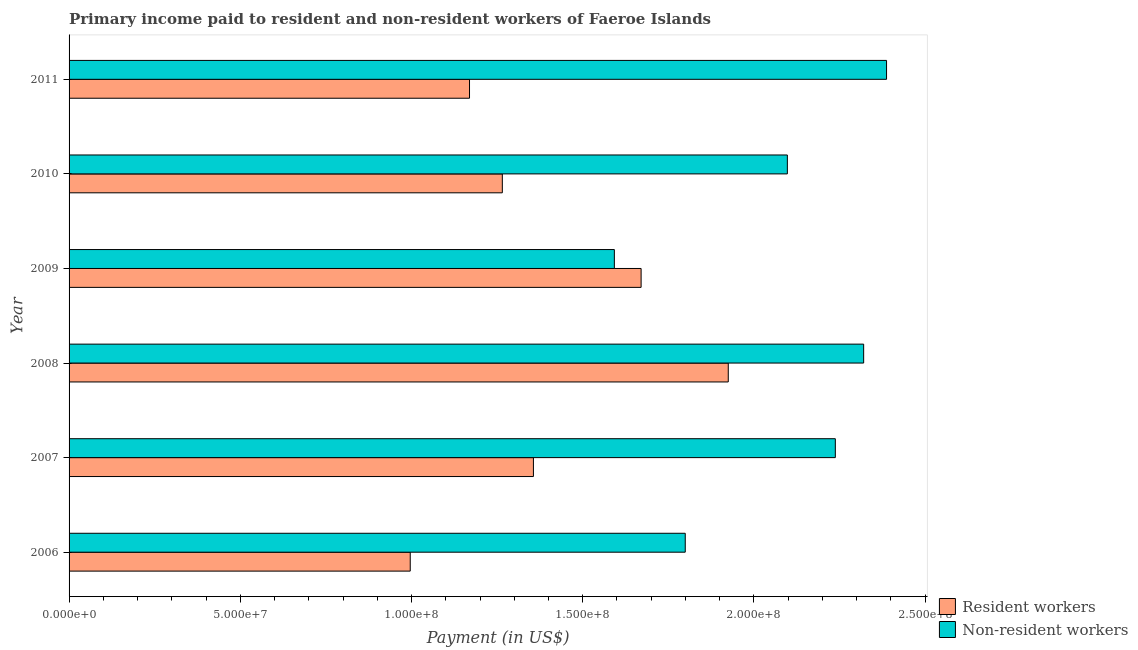How many different coloured bars are there?
Provide a short and direct response. 2. How many groups of bars are there?
Offer a very short reply. 6. Are the number of bars per tick equal to the number of legend labels?
Make the answer very short. Yes. Are the number of bars on each tick of the Y-axis equal?
Your answer should be compact. Yes. How many bars are there on the 1st tick from the top?
Your answer should be compact. 2. How many bars are there on the 2nd tick from the bottom?
Ensure brevity in your answer.  2. In how many cases, is the number of bars for a given year not equal to the number of legend labels?
Keep it short and to the point. 0. What is the payment made to resident workers in 2011?
Offer a very short reply. 1.17e+08. Across all years, what is the maximum payment made to non-resident workers?
Your response must be concise. 2.39e+08. Across all years, what is the minimum payment made to resident workers?
Provide a succinct answer. 9.96e+07. In which year was the payment made to non-resident workers maximum?
Your answer should be compact. 2011. In which year was the payment made to non-resident workers minimum?
Keep it short and to the point. 2009. What is the total payment made to resident workers in the graph?
Your answer should be very brief. 8.38e+08. What is the difference between the payment made to non-resident workers in 2008 and that in 2009?
Your answer should be very brief. 7.28e+07. What is the difference between the payment made to non-resident workers in 2006 and the payment made to resident workers in 2011?
Offer a very short reply. 6.30e+07. What is the average payment made to resident workers per year?
Keep it short and to the point. 1.40e+08. In the year 2006, what is the difference between the payment made to non-resident workers and payment made to resident workers?
Provide a short and direct response. 8.03e+07. What is the ratio of the payment made to resident workers in 2006 to that in 2009?
Your response must be concise. 0.6. Is the difference between the payment made to non-resident workers in 2006 and 2009 greater than the difference between the payment made to resident workers in 2006 and 2009?
Keep it short and to the point. Yes. What is the difference between the highest and the second highest payment made to resident workers?
Give a very brief answer. 2.55e+07. What is the difference between the highest and the lowest payment made to resident workers?
Your answer should be very brief. 9.29e+07. In how many years, is the payment made to non-resident workers greater than the average payment made to non-resident workers taken over all years?
Your answer should be very brief. 4. Is the sum of the payment made to resident workers in 2006 and 2008 greater than the maximum payment made to non-resident workers across all years?
Ensure brevity in your answer.  Yes. What does the 2nd bar from the top in 2006 represents?
Offer a very short reply. Resident workers. What does the 2nd bar from the bottom in 2010 represents?
Your answer should be compact. Non-resident workers. How many bars are there?
Provide a succinct answer. 12. Are all the bars in the graph horizontal?
Your answer should be very brief. Yes. Are the values on the major ticks of X-axis written in scientific E-notation?
Give a very brief answer. Yes. How are the legend labels stacked?
Keep it short and to the point. Vertical. What is the title of the graph?
Provide a short and direct response. Primary income paid to resident and non-resident workers of Faeroe Islands. What is the label or title of the X-axis?
Your answer should be very brief. Payment (in US$). What is the label or title of the Y-axis?
Give a very brief answer. Year. What is the Payment (in US$) in Resident workers in 2006?
Keep it short and to the point. 9.96e+07. What is the Payment (in US$) in Non-resident workers in 2006?
Offer a terse response. 1.80e+08. What is the Payment (in US$) in Resident workers in 2007?
Provide a short and direct response. 1.36e+08. What is the Payment (in US$) of Non-resident workers in 2007?
Your response must be concise. 2.24e+08. What is the Payment (in US$) of Resident workers in 2008?
Offer a very short reply. 1.92e+08. What is the Payment (in US$) in Non-resident workers in 2008?
Make the answer very short. 2.32e+08. What is the Payment (in US$) in Resident workers in 2009?
Your response must be concise. 1.67e+08. What is the Payment (in US$) in Non-resident workers in 2009?
Provide a short and direct response. 1.59e+08. What is the Payment (in US$) in Resident workers in 2010?
Your answer should be very brief. 1.27e+08. What is the Payment (in US$) of Non-resident workers in 2010?
Your answer should be compact. 2.10e+08. What is the Payment (in US$) of Resident workers in 2011?
Offer a terse response. 1.17e+08. What is the Payment (in US$) in Non-resident workers in 2011?
Keep it short and to the point. 2.39e+08. Across all years, what is the maximum Payment (in US$) of Resident workers?
Make the answer very short. 1.92e+08. Across all years, what is the maximum Payment (in US$) of Non-resident workers?
Ensure brevity in your answer.  2.39e+08. Across all years, what is the minimum Payment (in US$) in Resident workers?
Keep it short and to the point. 9.96e+07. Across all years, what is the minimum Payment (in US$) in Non-resident workers?
Make the answer very short. 1.59e+08. What is the total Payment (in US$) in Resident workers in the graph?
Your answer should be very brief. 8.38e+08. What is the total Payment (in US$) in Non-resident workers in the graph?
Ensure brevity in your answer.  1.24e+09. What is the difference between the Payment (in US$) in Resident workers in 2006 and that in 2007?
Offer a terse response. -3.60e+07. What is the difference between the Payment (in US$) in Non-resident workers in 2006 and that in 2007?
Ensure brevity in your answer.  -4.38e+07. What is the difference between the Payment (in US$) of Resident workers in 2006 and that in 2008?
Offer a very short reply. -9.29e+07. What is the difference between the Payment (in US$) of Non-resident workers in 2006 and that in 2008?
Make the answer very short. -5.21e+07. What is the difference between the Payment (in US$) of Resident workers in 2006 and that in 2009?
Offer a terse response. -6.74e+07. What is the difference between the Payment (in US$) in Non-resident workers in 2006 and that in 2009?
Keep it short and to the point. 2.07e+07. What is the difference between the Payment (in US$) in Resident workers in 2006 and that in 2010?
Make the answer very short. -2.69e+07. What is the difference between the Payment (in US$) in Non-resident workers in 2006 and that in 2010?
Your answer should be very brief. -2.98e+07. What is the difference between the Payment (in US$) of Resident workers in 2006 and that in 2011?
Offer a terse response. -1.73e+07. What is the difference between the Payment (in US$) of Non-resident workers in 2006 and that in 2011?
Your answer should be compact. -5.88e+07. What is the difference between the Payment (in US$) in Resident workers in 2007 and that in 2008?
Offer a terse response. -5.69e+07. What is the difference between the Payment (in US$) of Non-resident workers in 2007 and that in 2008?
Your answer should be compact. -8.27e+06. What is the difference between the Payment (in US$) in Resident workers in 2007 and that in 2009?
Give a very brief answer. -3.14e+07. What is the difference between the Payment (in US$) in Non-resident workers in 2007 and that in 2009?
Provide a short and direct response. 6.45e+07. What is the difference between the Payment (in US$) of Resident workers in 2007 and that in 2010?
Your answer should be very brief. 9.08e+06. What is the difference between the Payment (in US$) in Non-resident workers in 2007 and that in 2010?
Make the answer very short. 1.40e+07. What is the difference between the Payment (in US$) in Resident workers in 2007 and that in 2011?
Keep it short and to the point. 1.87e+07. What is the difference between the Payment (in US$) of Non-resident workers in 2007 and that in 2011?
Provide a short and direct response. -1.50e+07. What is the difference between the Payment (in US$) of Resident workers in 2008 and that in 2009?
Your answer should be very brief. 2.55e+07. What is the difference between the Payment (in US$) of Non-resident workers in 2008 and that in 2009?
Provide a succinct answer. 7.28e+07. What is the difference between the Payment (in US$) of Resident workers in 2008 and that in 2010?
Your response must be concise. 6.60e+07. What is the difference between the Payment (in US$) of Non-resident workers in 2008 and that in 2010?
Give a very brief answer. 2.23e+07. What is the difference between the Payment (in US$) in Resident workers in 2008 and that in 2011?
Your response must be concise. 7.56e+07. What is the difference between the Payment (in US$) of Non-resident workers in 2008 and that in 2011?
Ensure brevity in your answer.  -6.68e+06. What is the difference between the Payment (in US$) of Resident workers in 2009 and that in 2010?
Your answer should be compact. 4.05e+07. What is the difference between the Payment (in US$) of Non-resident workers in 2009 and that in 2010?
Your response must be concise. -5.05e+07. What is the difference between the Payment (in US$) in Resident workers in 2009 and that in 2011?
Ensure brevity in your answer.  5.01e+07. What is the difference between the Payment (in US$) of Non-resident workers in 2009 and that in 2011?
Your response must be concise. -7.95e+07. What is the difference between the Payment (in US$) of Resident workers in 2010 and that in 2011?
Your response must be concise. 9.58e+06. What is the difference between the Payment (in US$) of Non-resident workers in 2010 and that in 2011?
Your answer should be compact. -2.90e+07. What is the difference between the Payment (in US$) in Resident workers in 2006 and the Payment (in US$) in Non-resident workers in 2007?
Keep it short and to the point. -1.24e+08. What is the difference between the Payment (in US$) in Resident workers in 2006 and the Payment (in US$) in Non-resident workers in 2008?
Keep it short and to the point. -1.32e+08. What is the difference between the Payment (in US$) of Resident workers in 2006 and the Payment (in US$) of Non-resident workers in 2009?
Offer a terse response. -5.96e+07. What is the difference between the Payment (in US$) in Resident workers in 2006 and the Payment (in US$) in Non-resident workers in 2010?
Your response must be concise. -1.10e+08. What is the difference between the Payment (in US$) of Resident workers in 2006 and the Payment (in US$) of Non-resident workers in 2011?
Keep it short and to the point. -1.39e+08. What is the difference between the Payment (in US$) in Resident workers in 2007 and the Payment (in US$) in Non-resident workers in 2008?
Your response must be concise. -9.64e+07. What is the difference between the Payment (in US$) in Resident workers in 2007 and the Payment (in US$) in Non-resident workers in 2009?
Your response must be concise. -2.36e+07. What is the difference between the Payment (in US$) in Resident workers in 2007 and the Payment (in US$) in Non-resident workers in 2010?
Your answer should be very brief. -7.42e+07. What is the difference between the Payment (in US$) in Resident workers in 2007 and the Payment (in US$) in Non-resident workers in 2011?
Provide a succinct answer. -1.03e+08. What is the difference between the Payment (in US$) in Resident workers in 2008 and the Payment (in US$) in Non-resident workers in 2009?
Give a very brief answer. 3.33e+07. What is the difference between the Payment (in US$) of Resident workers in 2008 and the Payment (in US$) of Non-resident workers in 2010?
Your response must be concise. -1.73e+07. What is the difference between the Payment (in US$) in Resident workers in 2008 and the Payment (in US$) in Non-resident workers in 2011?
Provide a short and direct response. -4.62e+07. What is the difference between the Payment (in US$) of Resident workers in 2009 and the Payment (in US$) of Non-resident workers in 2010?
Give a very brief answer. -4.27e+07. What is the difference between the Payment (in US$) in Resident workers in 2009 and the Payment (in US$) in Non-resident workers in 2011?
Offer a terse response. -7.17e+07. What is the difference between the Payment (in US$) in Resident workers in 2010 and the Payment (in US$) in Non-resident workers in 2011?
Provide a short and direct response. -1.12e+08. What is the average Payment (in US$) of Resident workers per year?
Offer a terse response. 1.40e+08. What is the average Payment (in US$) of Non-resident workers per year?
Make the answer very short. 2.07e+08. In the year 2006, what is the difference between the Payment (in US$) of Resident workers and Payment (in US$) of Non-resident workers?
Offer a very short reply. -8.03e+07. In the year 2007, what is the difference between the Payment (in US$) of Resident workers and Payment (in US$) of Non-resident workers?
Your answer should be compact. -8.82e+07. In the year 2008, what is the difference between the Payment (in US$) in Resident workers and Payment (in US$) in Non-resident workers?
Give a very brief answer. -3.95e+07. In the year 2009, what is the difference between the Payment (in US$) in Resident workers and Payment (in US$) in Non-resident workers?
Your response must be concise. 7.81e+06. In the year 2010, what is the difference between the Payment (in US$) of Resident workers and Payment (in US$) of Non-resident workers?
Make the answer very short. -8.32e+07. In the year 2011, what is the difference between the Payment (in US$) of Resident workers and Payment (in US$) of Non-resident workers?
Ensure brevity in your answer.  -1.22e+08. What is the ratio of the Payment (in US$) of Resident workers in 2006 to that in 2007?
Your answer should be very brief. 0.73. What is the ratio of the Payment (in US$) in Non-resident workers in 2006 to that in 2007?
Give a very brief answer. 0.8. What is the ratio of the Payment (in US$) in Resident workers in 2006 to that in 2008?
Offer a very short reply. 0.52. What is the ratio of the Payment (in US$) in Non-resident workers in 2006 to that in 2008?
Your answer should be very brief. 0.78. What is the ratio of the Payment (in US$) of Resident workers in 2006 to that in 2009?
Ensure brevity in your answer.  0.6. What is the ratio of the Payment (in US$) in Non-resident workers in 2006 to that in 2009?
Keep it short and to the point. 1.13. What is the ratio of the Payment (in US$) in Resident workers in 2006 to that in 2010?
Offer a terse response. 0.79. What is the ratio of the Payment (in US$) of Non-resident workers in 2006 to that in 2010?
Your answer should be compact. 0.86. What is the ratio of the Payment (in US$) of Resident workers in 2006 to that in 2011?
Your answer should be very brief. 0.85. What is the ratio of the Payment (in US$) of Non-resident workers in 2006 to that in 2011?
Offer a terse response. 0.75. What is the ratio of the Payment (in US$) in Resident workers in 2007 to that in 2008?
Keep it short and to the point. 0.7. What is the ratio of the Payment (in US$) in Non-resident workers in 2007 to that in 2008?
Provide a succinct answer. 0.96. What is the ratio of the Payment (in US$) of Resident workers in 2007 to that in 2009?
Keep it short and to the point. 0.81. What is the ratio of the Payment (in US$) in Non-resident workers in 2007 to that in 2009?
Make the answer very short. 1.41. What is the ratio of the Payment (in US$) in Resident workers in 2007 to that in 2010?
Offer a terse response. 1.07. What is the ratio of the Payment (in US$) in Non-resident workers in 2007 to that in 2010?
Your response must be concise. 1.07. What is the ratio of the Payment (in US$) of Resident workers in 2007 to that in 2011?
Your response must be concise. 1.16. What is the ratio of the Payment (in US$) in Non-resident workers in 2007 to that in 2011?
Your answer should be very brief. 0.94. What is the ratio of the Payment (in US$) in Resident workers in 2008 to that in 2009?
Give a very brief answer. 1.15. What is the ratio of the Payment (in US$) of Non-resident workers in 2008 to that in 2009?
Offer a terse response. 1.46. What is the ratio of the Payment (in US$) of Resident workers in 2008 to that in 2010?
Your answer should be very brief. 1.52. What is the ratio of the Payment (in US$) in Non-resident workers in 2008 to that in 2010?
Keep it short and to the point. 1.11. What is the ratio of the Payment (in US$) of Resident workers in 2008 to that in 2011?
Keep it short and to the point. 1.65. What is the ratio of the Payment (in US$) in Non-resident workers in 2008 to that in 2011?
Provide a succinct answer. 0.97. What is the ratio of the Payment (in US$) of Resident workers in 2009 to that in 2010?
Provide a succinct answer. 1.32. What is the ratio of the Payment (in US$) in Non-resident workers in 2009 to that in 2010?
Provide a short and direct response. 0.76. What is the ratio of the Payment (in US$) of Resident workers in 2009 to that in 2011?
Your response must be concise. 1.43. What is the ratio of the Payment (in US$) of Non-resident workers in 2009 to that in 2011?
Provide a succinct answer. 0.67. What is the ratio of the Payment (in US$) in Resident workers in 2010 to that in 2011?
Ensure brevity in your answer.  1.08. What is the ratio of the Payment (in US$) in Non-resident workers in 2010 to that in 2011?
Make the answer very short. 0.88. What is the difference between the highest and the second highest Payment (in US$) of Resident workers?
Offer a very short reply. 2.55e+07. What is the difference between the highest and the second highest Payment (in US$) in Non-resident workers?
Make the answer very short. 6.68e+06. What is the difference between the highest and the lowest Payment (in US$) of Resident workers?
Offer a terse response. 9.29e+07. What is the difference between the highest and the lowest Payment (in US$) in Non-resident workers?
Give a very brief answer. 7.95e+07. 